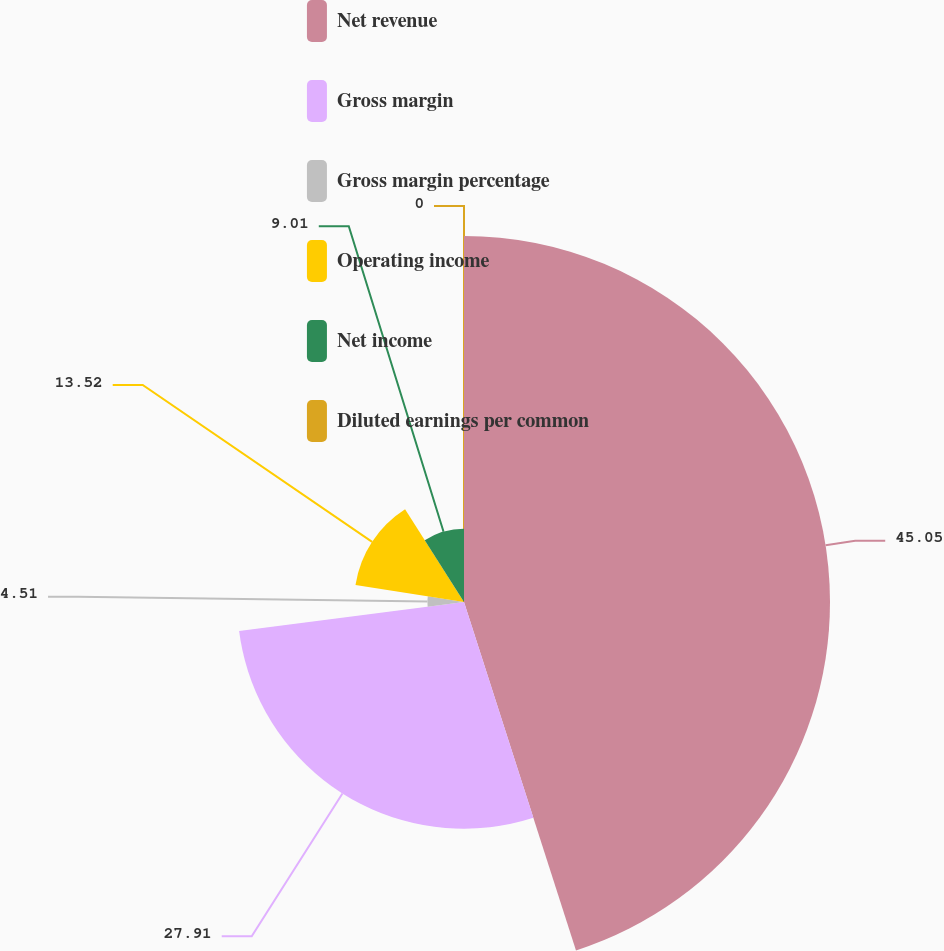Convert chart. <chart><loc_0><loc_0><loc_500><loc_500><pie_chart><fcel>Net revenue<fcel>Gross margin<fcel>Gross margin percentage<fcel>Operating income<fcel>Net income<fcel>Diluted earnings per common<nl><fcel>45.05%<fcel>27.91%<fcel>4.51%<fcel>13.52%<fcel>9.01%<fcel>0.0%<nl></chart> 